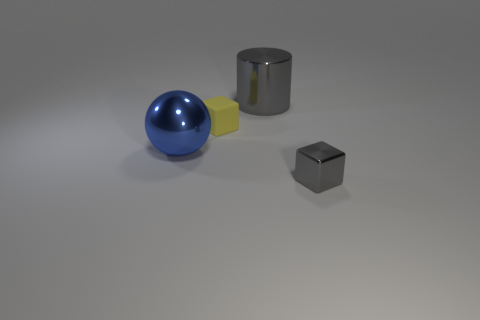What number of cylinders are either yellow objects or gray things?
Keep it short and to the point. 1. There is another tiny object that is the same shape as the yellow object; what is its material?
Make the answer very short. Metal. There is a cylinder that is made of the same material as the blue ball; what size is it?
Your response must be concise. Large. There is a big object in front of the gray cylinder; is it the same shape as the gray metal thing behind the tiny metallic cube?
Your response must be concise. No. There is a large cylinder that is made of the same material as the blue sphere; what color is it?
Keep it short and to the point. Gray. There is a gray object in front of the tiny yellow cube; is its size the same as the gray object left of the tiny metal cube?
Offer a terse response. No. What is the shape of the metal thing that is to the left of the small gray cube and in front of the big metal cylinder?
Provide a succinct answer. Sphere. Is there a cylinder made of the same material as the large blue thing?
Provide a short and direct response. Yes. What material is the block that is the same color as the large metallic cylinder?
Provide a short and direct response. Metal. Are the tiny object that is to the right of the yellow rubber block and the large blue sphere that is behind the tiny metal object made of the same material?
Provide a succinct answer. Yes. 